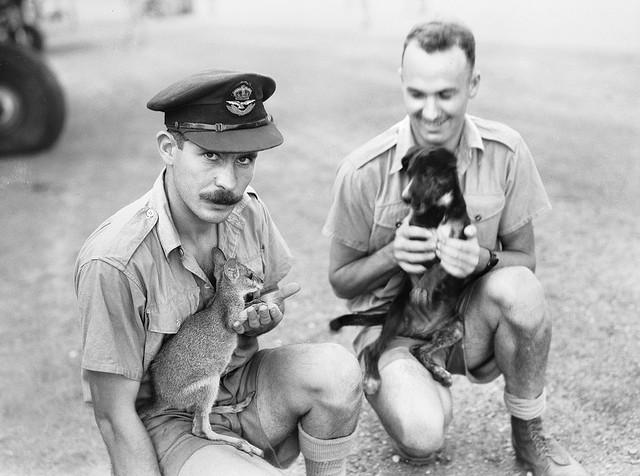What type of hat is the man wearing?
Concise answer only. Military. Do these men like animals?
Quick response, please. Yes. What is he holding in his hand?
Keep it brief. Kangaroo. 